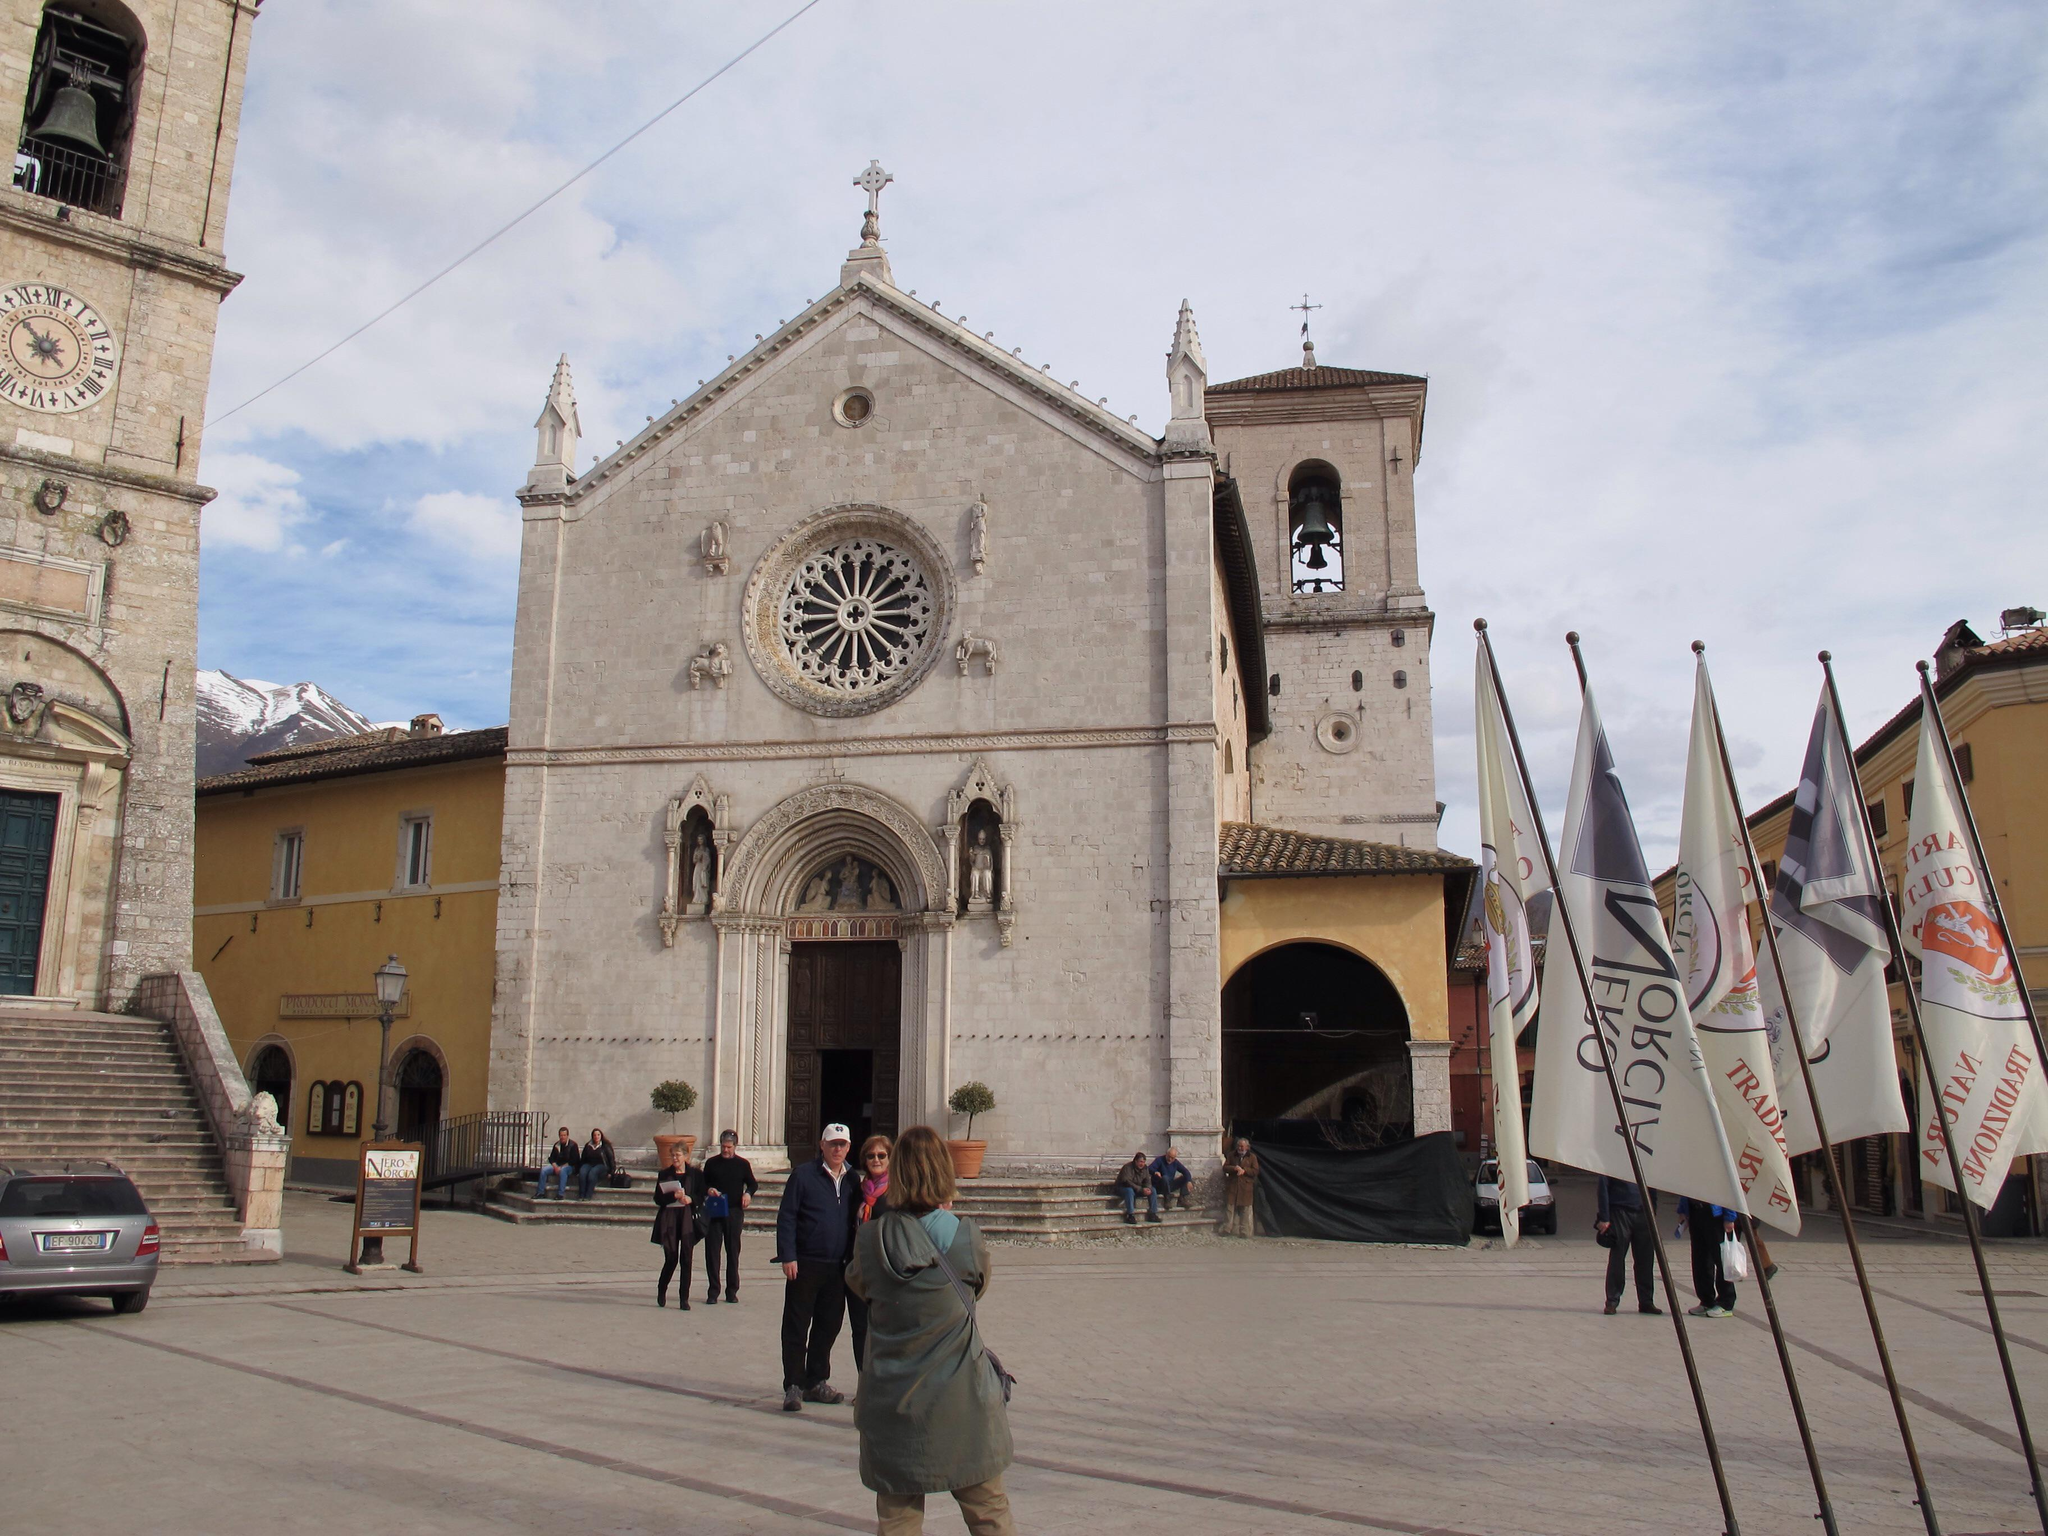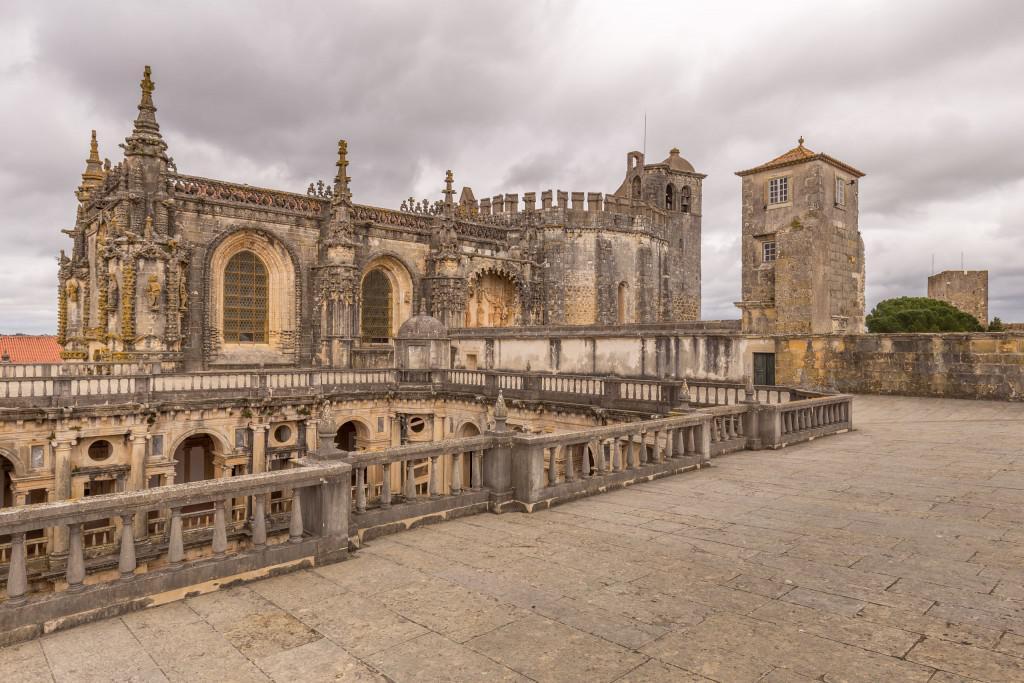The first image is the image on the left, the second image is the image on the right. Evaluate the accuracy of this statement regarding the images: "There are humans in at least one of the images.". Is it true? Answer yes or no. Yes. The first image is the image on the left, the second image is the image on the right. Evaluate the accuracy of this statement regarding the images: "There is a round window on top of the main door of a cathedral in the left image.". Is it true? Answer yes or no. Yes. 